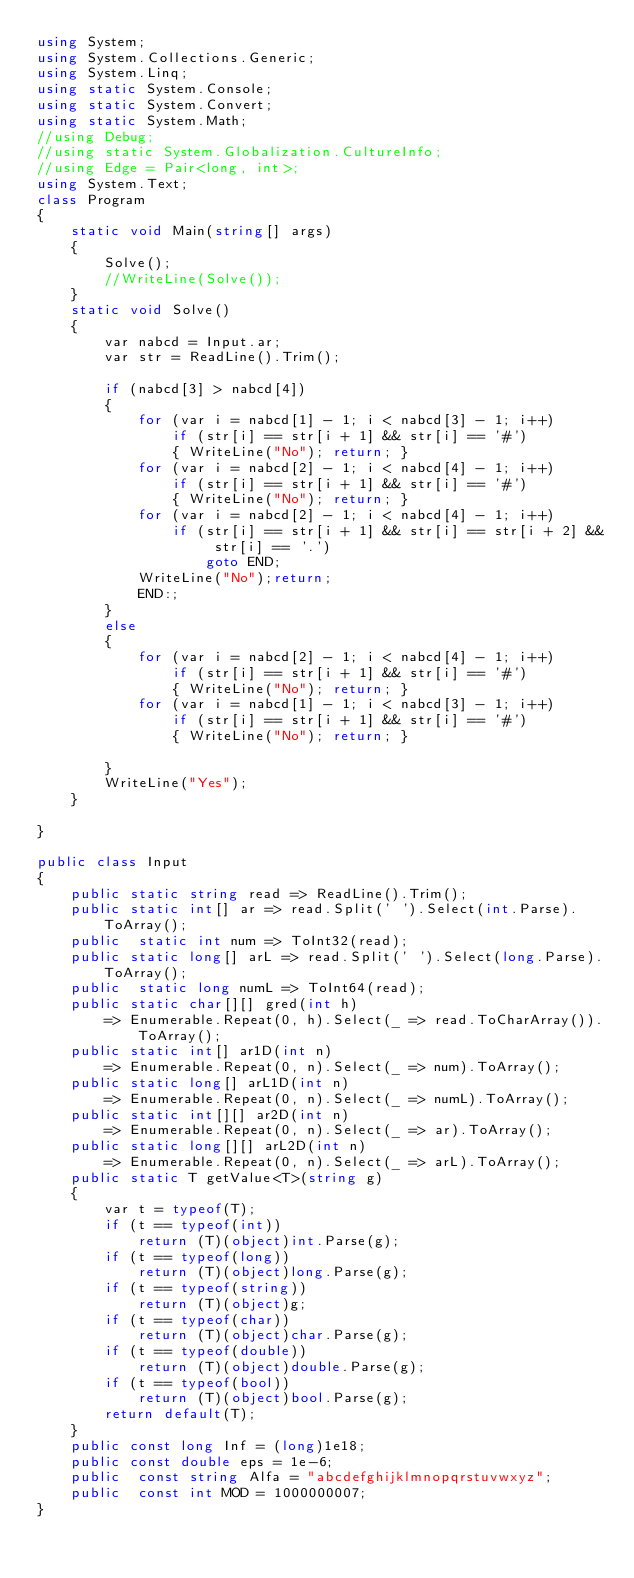<code> <loc_0><loc_0><loc_500><loc_500><_C#_>using System;
using System.Collections.Generic;
using System.Linq;
using static System.Console;
using static System.Convert;
using static System.Math;
//using Debug;
//using static System.Globalization.CultureInfo;
//using Edge = Pair<long, int>;
using System.Text;
class Program
{ 
    static void Main(string[] args)
    {
        Solve();
        //WriteLine(Solve());
    }
    static void Solve()
    {
        var nabcd = Input.ar;
        var str = ReadLine().Trim();

        if (nabcd[3] > nabcd[4])
        {
            for (var i = nabcd[1] - 1; i < nabcd[3] - 1; i++)
                if (str[i] == str[i + 1] && str[i] == '#')
                { WriteLine("No"); return; }
            for (var i = nabcd[2] - 1; i < nabcd[4] - 1; i++)
                if (str[i] == str[i + 1] && str[i] == '#')
                { WriteLine("No"); return; }
            for (var i = nabcd[2] - 1; i < nabcd[4] - 1; i++)
                if (str[i] == str[i + 1] && str[i] == str[i + 2] && str[i] == '.')
                    goto END;
            WriteLine("No");return;
            END:;
        }
        else
        {
            for (var i = nabcd[2] - 1; i < nabcd[4] - 1; i++)
                if (str[i] == str[i + 1] && str[i] == '#')
                { WriteLine("No"); return; }
            for (var i = nabcd[1] - 1; i < nabcd[3] - 1; i++)
                if (str[i] == str[i + 1] && str[i] == '#')
                { WriteLine("No"); return; }

        }
        WriteLine("Yes");
    }
    
}

public class Input
{
    public static string read => ReadLine().Trim();
    public static int[] ar => read.Split(' ').Select(int.Parse).ToArray();
    public  static int num => ToInt32(read);
    public static long[] arL => read.Split(' ').Select(long.Parse).ToArray();
    public  static long numL => ToInt64(read);
    public static char[][] gred(int h) 
        => Enumerable.Repeat(0, h).Select(_ => read.ToCharArray()).ToArray();
    public static int[] ar1D(int n)
        => Enumerable.Repeat(0, n).Select(_ => num).ToArray();
    public static long[] arL1D(int n)
        => Enumerable.Repeat(0, n).Select(_ => numL).ToArray();
    public static int[][] ar2D(int n)
        => Enumerable.Repeat(0, n).Select(_ => ar).ToArray();
    public static long[][] arL2D(int n)
        => Enumerable.Repeat(0, n).Select(_ => arL).ToArray();
    public static T getValue<T>(string g)
    {
        var t = typeof(T);
        if (t == typeof(int))
            return (T)(object)int.Parse(g);
        if (t == typeof(long))
            return (T)(object)long.Parse(g);
        if (t == typeof(string))
            return (T)(object)g;
        if (t == typeof(char))
            return (T)(object)char.Parse(g);
        if (t == typeof(double))
            return (T)(object)double.Parse(g);
        if (t == typeof(bool))
            return (T)(object)bool.Parse(g);
        return default(T);
    }
    public const long Inf = (long)1e18;
    public const double eps = 1e-6;
    public  const string Alfa = "abcdefghijklmnopqrstuvwxyz";
    public  const int MOD = 1000000007;
}
</code> 